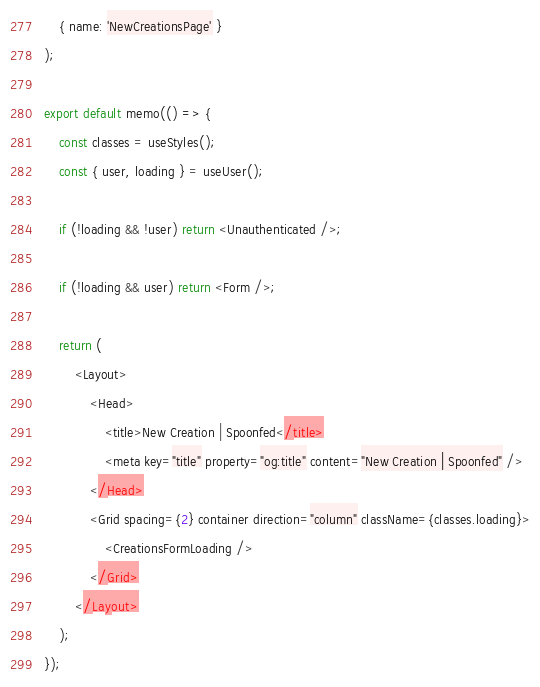Convert code to text. <code><loc_0><loc_0><loc_500><loc_500><_JavaScript_>	{ name: 'NewCreationsPage' }
);

export default memo(() => {
	const classes = useStyles();
	const { user, loading } = useUser();

	if (!loading && !user) return <Unauthenticated />;

	if (!loading && user) return <Form />;

	return (
		<Layout>
			<Head>
				<title>New Creation | Spoonfed</title>
				<meta key="title" property="og:title" content="New Creation | Spoonfed" />
			</Head>
			<Grid spacing={2} container direction="column" className={classes.loading}>
				<CreationsFormLoading />
			</Grid>
		</Layout>
	);
});
</code> 